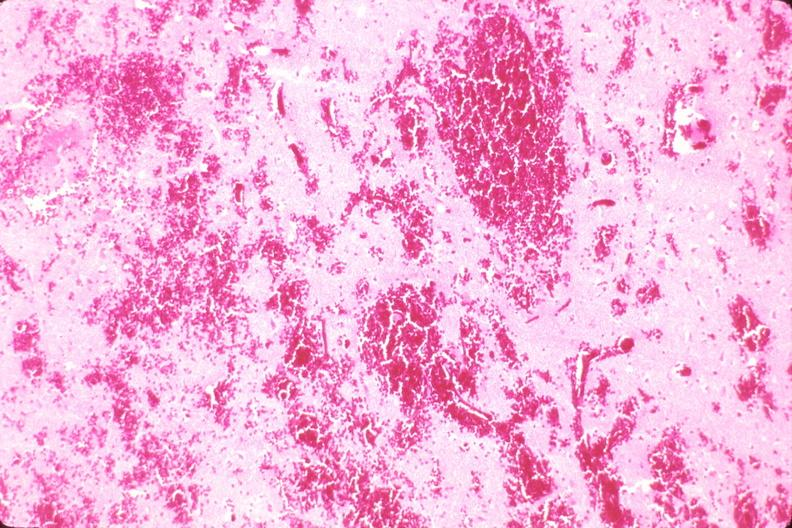what is present?
Answer the question using a single word or phrase. Nervous 